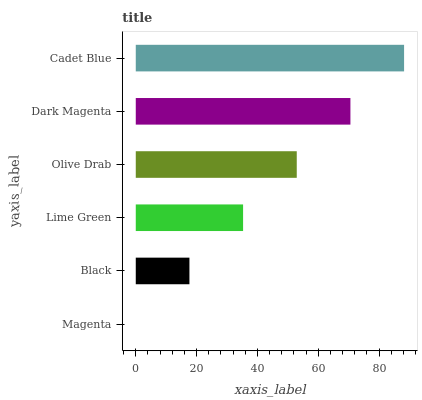Is Magenta the minimum?
Answer yes or no. Yes. Is Cadet Blue the maximum?
Answer yes or no. Yes. Is Black the minimum?
Answer yes or no. No. Is Black the maximum?
Answer yes or no. No. Is Black greater than Magenta?
Answer yes or no. Yes. Is Magenta less than Black?
Answer yes or no. Yes. Is Magenta greater than Black?
Answer yes or no. No. Is Black less than Magenta?
Answer yes or no. No. Is Olive Drab the high median?
Answer yes or no. Yes. Is Lime Green the low median?
Answer yes or no. Yes. Is Lime Green the high median?
Answer yes or no. No. Is Cadet Blue the low median?
Answer yes or no. No. 